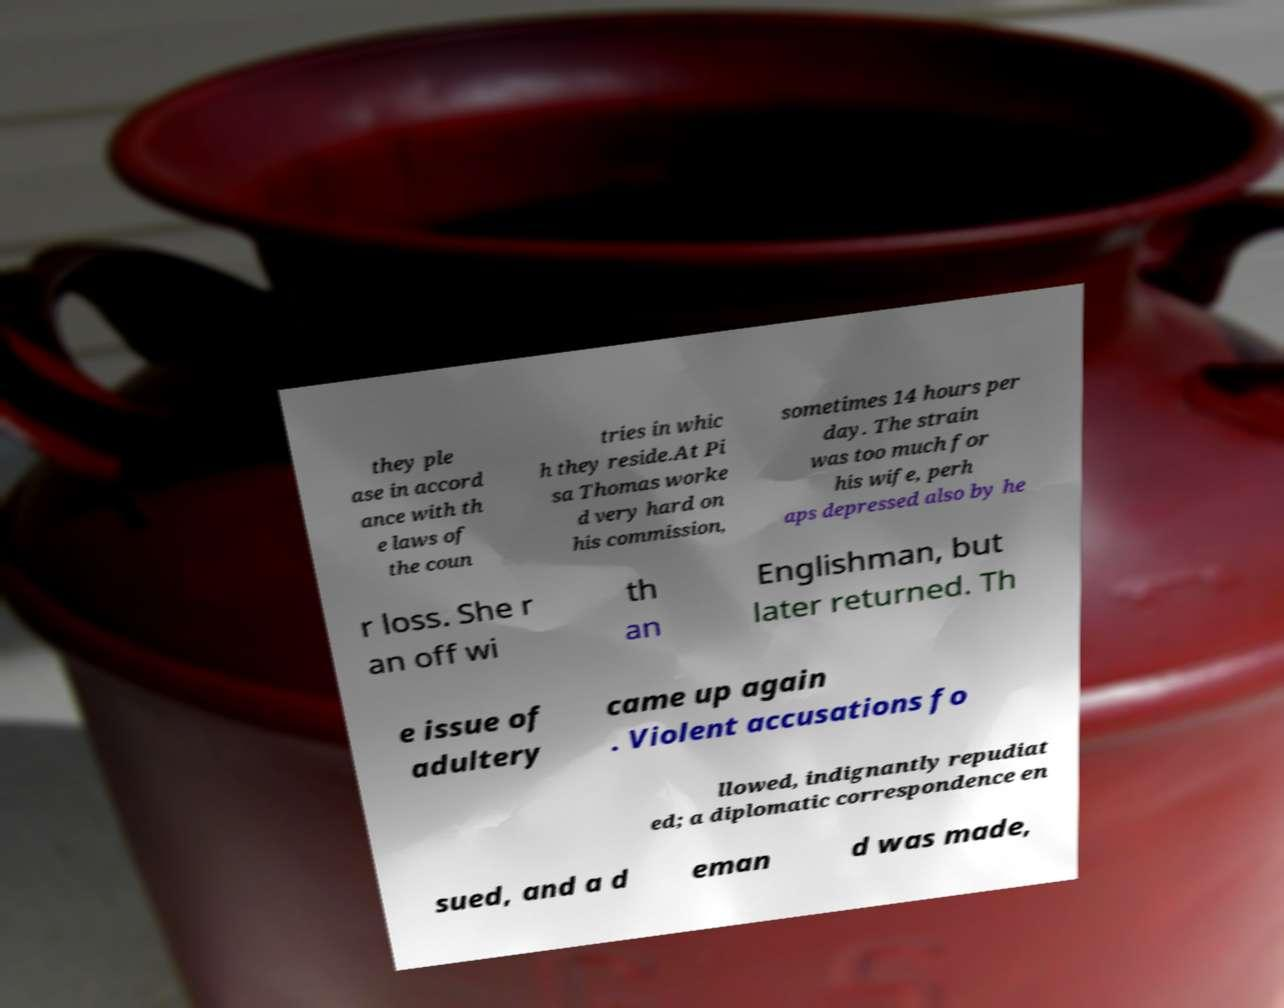I need the written content from this picture converted into text. Can you do that? they ple ase in accord ance with th e laws of the coun tries in whic h they reside.At Pi sa Thomas worke d very hard on his commission, sometimes 14 hours per day. The strain was too much for his wife, perh aps depressed also by he r loss. She r an off wi th an Englishman, but later returned. Th e issue of adultery came up again . Violent accusations fo llowed, indignantly repudiat ed; a diplomatic correspondence en sued, and a d eman d was made, 